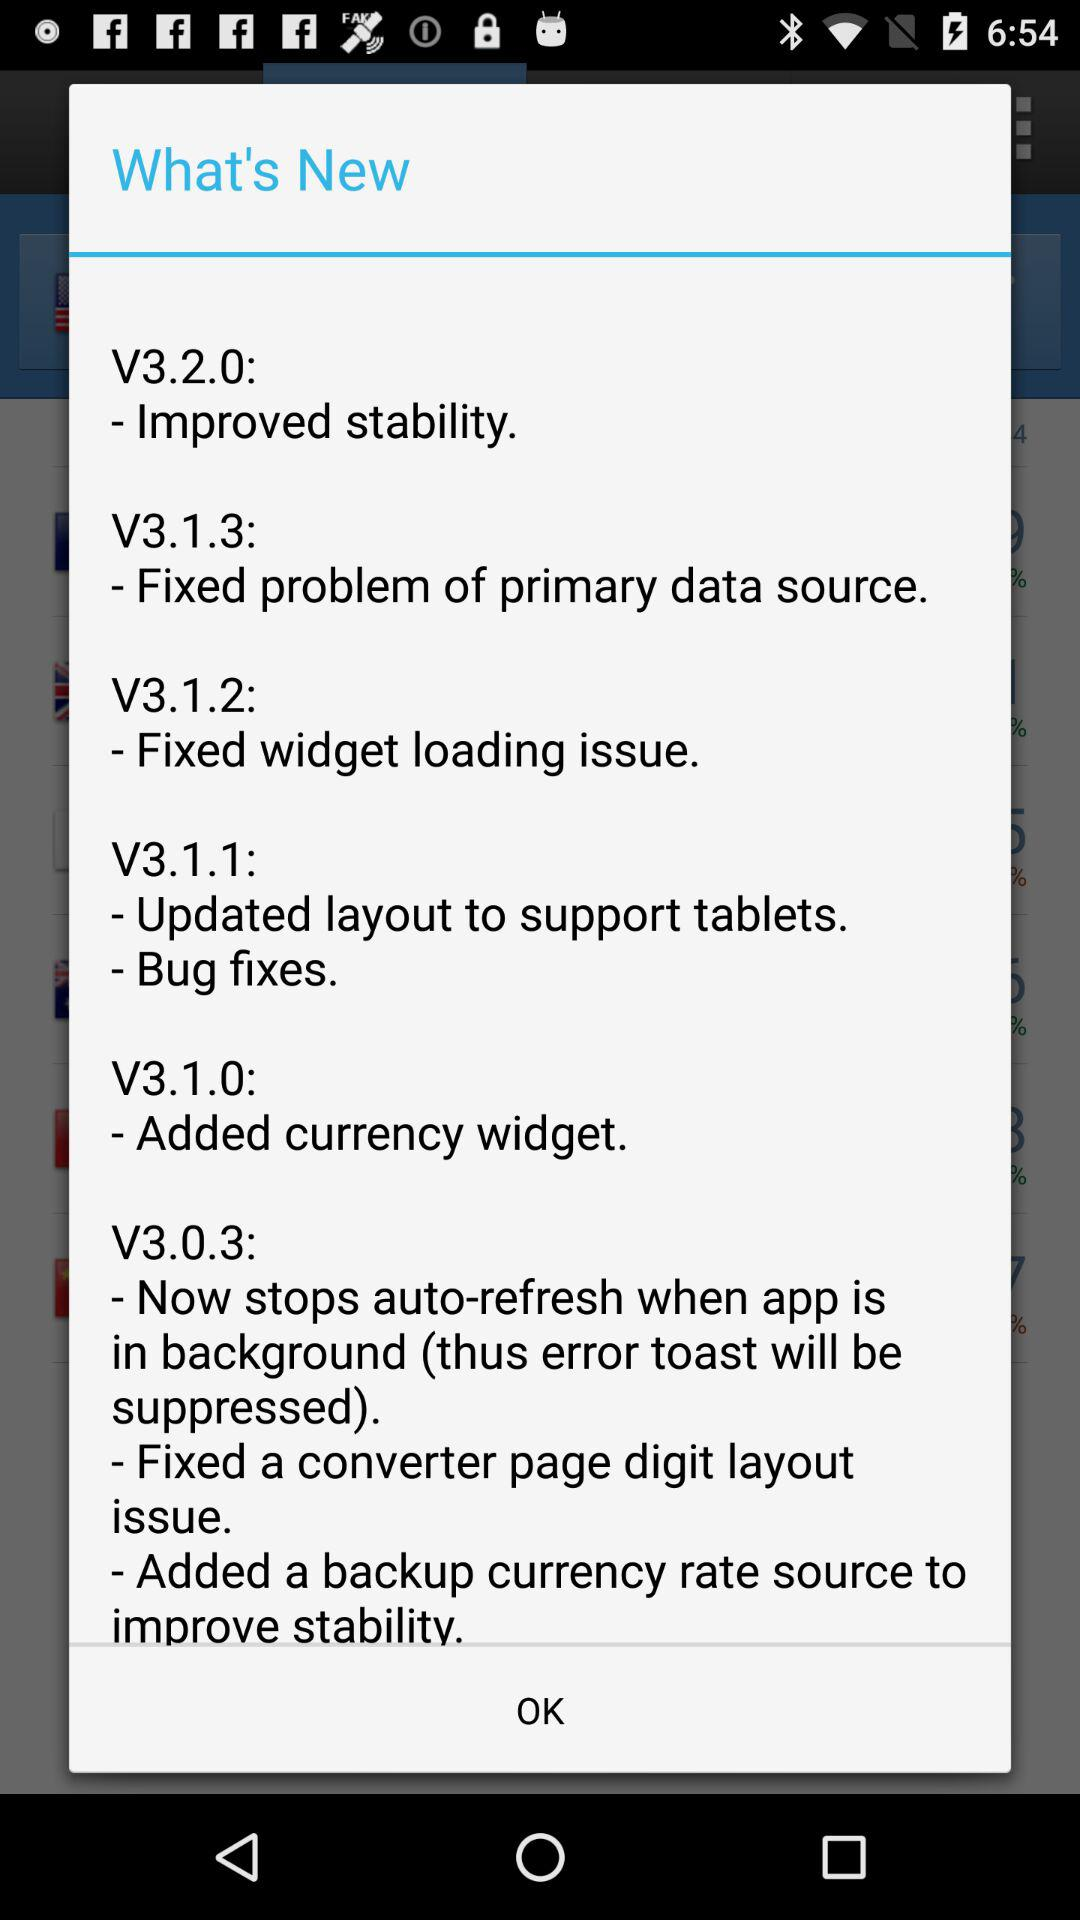What are the new features in V3.0.3? The new features in V3.0.3 are "Now stops auto-refresh when app is in background (thus error toast will be suppressed)", "Fixed a converter page digit layout issue" and "Added a backup currency rate source to improve stability". 